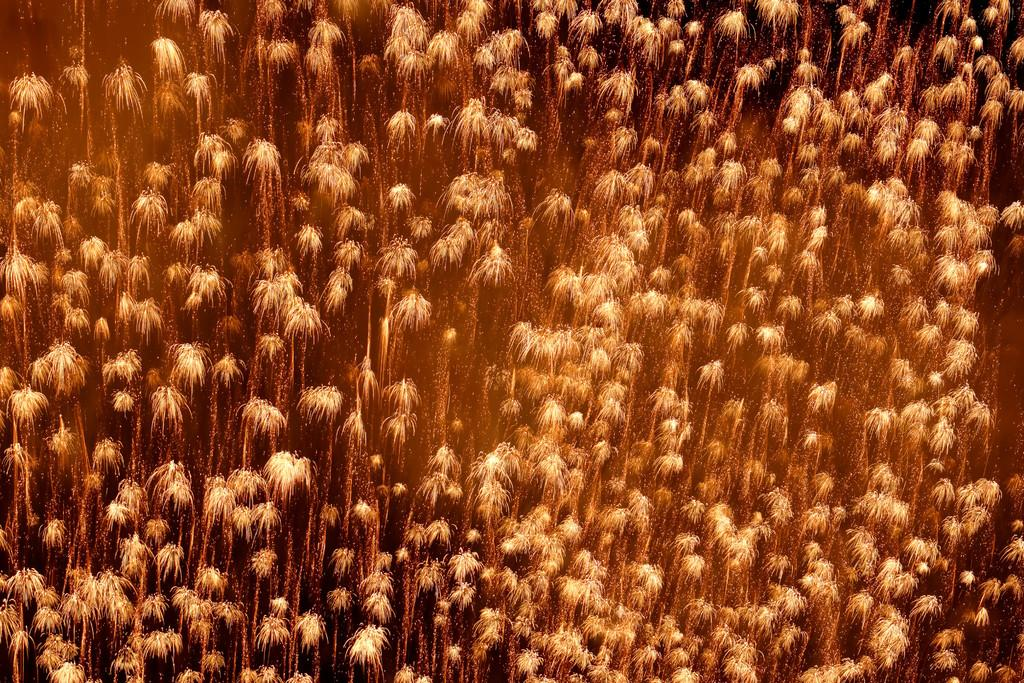What is the color of the objects in the image? The objects in the image are golden-colored. What color can be seen in the background of the image? There is black color visible in the background of the image. Can you see friends playing in the image? There is no indication of friends playing in the image. Is there any air visible in the image? The image does not show any air; it only shows the golden-colored objects and the black background. Are there any cobwebs present in the image? There is no mention of cobwebs in the provided facts, and therefore we cannot determine their presence in the image. 